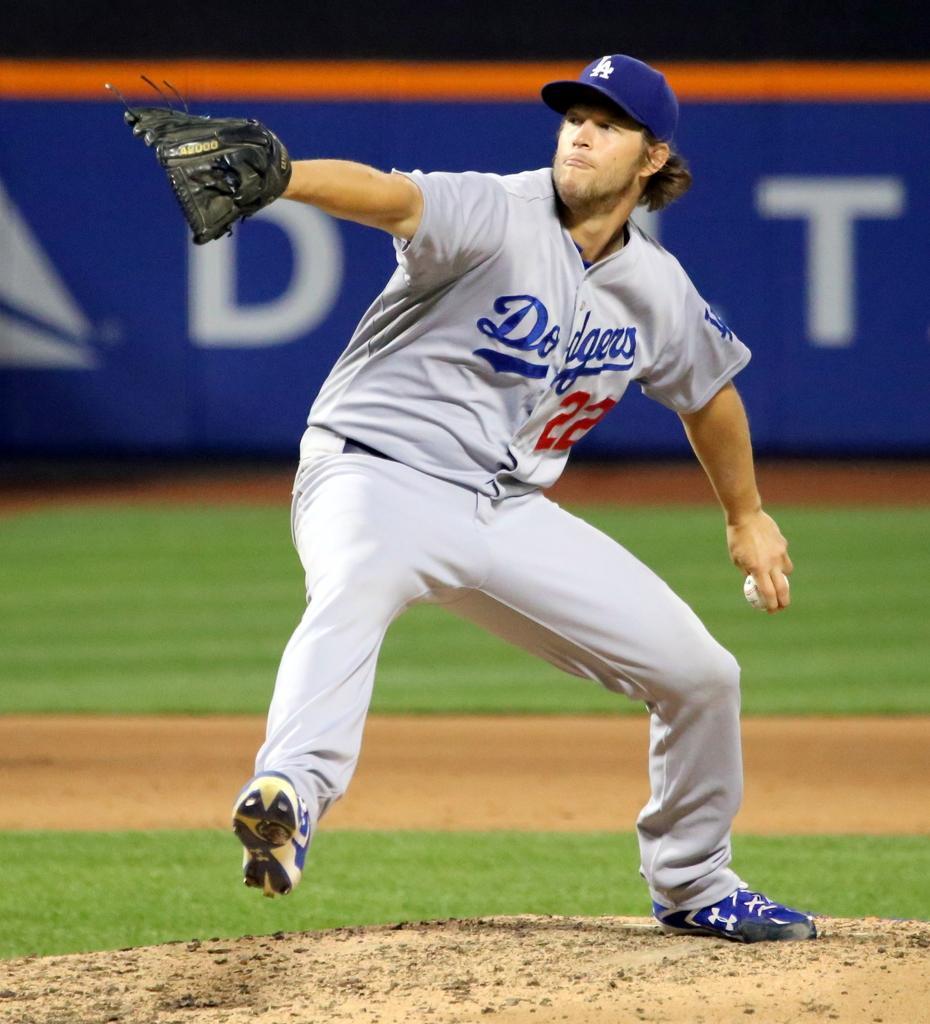How would you summarize this image in a sentence or two? Here in this picture we can see a person standing in a ground and we can see gloves and cap on him and he is trying to throw he ball present in his hand and we can see some part of ground is covered with grass over there. 